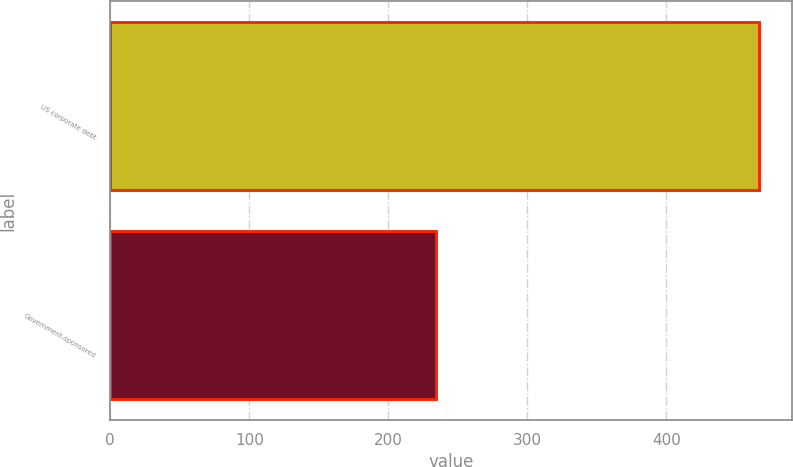<chart> <loc_0><loc_0><loc_500><loc_500><bar_chart><fcel>US corporate debt<fcel>Government-sponsored<nl><fcel>467<fcel>234<nl></chart> 